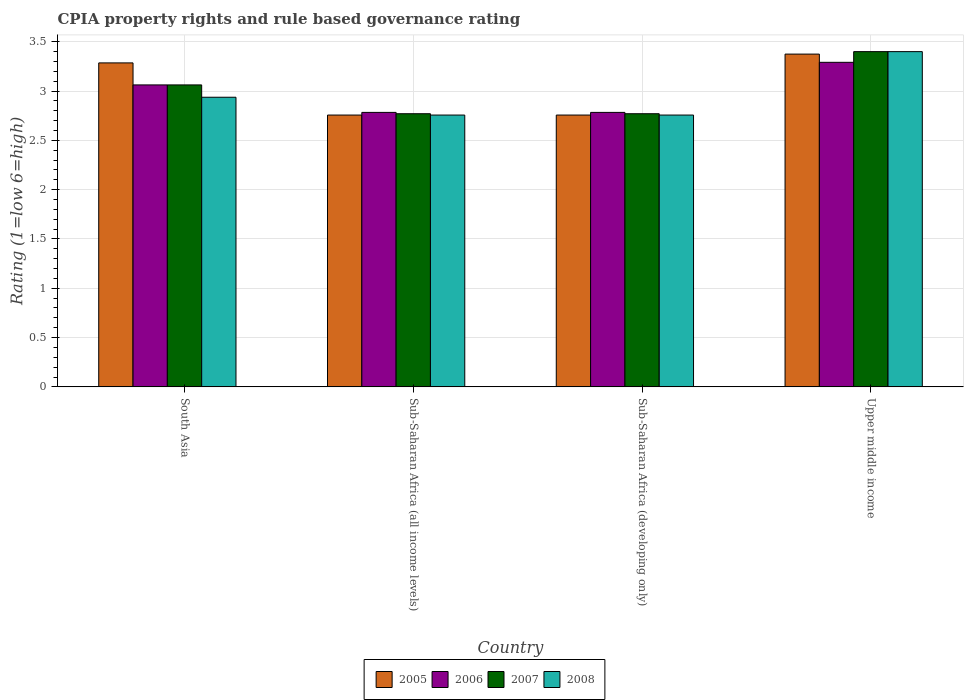How many different coloured bars are there?
Give a very brief answer. 4. Are the number of bars on each tick of the X-axis equal?
Give a very brief answer. Yes. What is the label of the 1st group of bars from the left?
Your answer should be compact. South Asia. In how many cases, is the number of bars for a given country not equal to the number of legend labels?
Provide a short and direct response. 0. What is the CPIA rating in 2008 in Sub-Saharan Africa (developing only)?
Your answer should be very brief. 2.76. Across all countries, what is the maximum CPIA rating in 2005?
Ensure brevity in your answer.  3.38. Across all countries, what is the minimum CPIA rating in 2007?
Provide a short and direct response. 2.77. In which country was the CPIA rating in 2007 maximum?
Ensure brevity in your answer.  Upper middle income. In which country was the CPIA rating in 2007 minimum?
Make the answer very short. Sub-Saharan Africa (all income levels). What is the total CPIA rating in 2006 in the graph?
Make the answer very short. 11.92. What is the difference between the CPIA rating in 2008 in South Asia and that in Sub-Saharan Africa (all income levels)?
Offer a very short reply. 0.18. What is the difference between the CPIA rating in 2008 in South Asia and the CPIA rating in 2007 in Upper middle income?
Offer a terse response. -0.46. What is the average CPIA rating in 2008 per country?
Offer a very short reply. 2.96. In how many countries, is the CPIA rating in 2006 greater than 1?
Offer a terse response. 4. What is the ratio of the CPIA rating in 2006 in South Asia to that in Sub-Saharan Africa (developing only)?
Offer a very short reply. 1.1. Is the difference between the CPIA rating in 2005 in Sub-Saharan Africa (developing only) and Upper middle income greater than the difference between the CPIA rating in 2008 in Sub-Saharan Africa (developing only) and Upper middle income?
Offer a terse response. Yes. What is the difference between the highest and the second highest CPIA rating in 2008?
Offer a terse response. -0.46. What is the difference between the highest and the lowest CPIA rating in 2005?
Make the answer very short. 0.62. What does the 3rd bar from the left in Sub-Saharan Africa (all income levels) represents?
Keep it short and to the point. 2007. How many countries are there in the graph?
Offer a very short reply. 4. What is the difference between two consecutive major ticks on the Y-axis?
Make the answer very short. 0.5. Does the graph contain any zero values?
Offer a terse response. No. Does the graph contain grids?
Give a very brief answer. Yes. How are the legend labels stacked?
Your response must be concise. Horizontal. What is the title of the graph?
Make the answer very short. CPIA property rights and rule based governance rating. Does "2008" appear as one of the legend labels in the graph?
Keep it short and to the point. Yes. What is the Rating (1=low 6=high) in 2005 in South Asia?
Provide a short and direct response. 3.29. What is the Rating (1=low 6=high) of 2006 in South Asia?
Give a very brief answer. 3.06. What is the Rating (1=low 6=high) of 2007 in South Asia?
Offer a very short reply. 3.06. What is the Rating (1=low 6=high) of 2008 in South Asia?
Your answer should be very brief. 2.94. What is the Rating (1=low 6=high) in 2005 in Sub-Saharan Africa (all income levels)?
Make the answer very short. 2.76. What is the Rating (1=low 6=high) of 2006 in Sub-Saharan Africa (all income levels)?
Make the answer very short. 2.78. What is the Rating (1=low 6=high) in 2007 in Sub-Saharan Africa (all income levels)?
Give a very brief answer. 2.77. What is the Rating (1=low 6=high) of 2008 in Sub-Saharan Africa (all income levels)?
Offer a terse response. 2.76. What is the Rating (1=low 6=high) of 2005 in Sub-Saharan Africa (developing only)?
Make the answer very short. 2.76. What is the Rating (1=low 6=high) in 2006 in Sub-Saharan Africa (developing only)?
Make the answer very short. 2.78. What is the Rating (1=low 6=high) of 2007 in Sub-Saharan Africa (developing only)?
Provide a succinct answer. 2.77. What is the Rating (1=low 6=high) of 2008 in Sub-Saharan Africa (developing only)?
Your answer should be compact. 2.76. What is the Rating (1=low 6=high) of 2005 in Upper middle income?
Your response must be concise. 3.38. What is the Rating (1=low 6=high) of 2006 in Upper middle income?
Provide a short and direct response. 3.29. What is the Rating (1=low 6=high) of 2007 in Upper middle income?
Offer a terse response. 3.4. Across all countries, what is the maximum Rating (1=low 6=high) in 2005?
Your response must be concise. 3.38. Across all countries, what is the maximum Rating (1=low 6=high) in 2006?
Provide a succinct answer. 3.29. Across all countries, what is the minimum Rating (1=low 6=high) of 2005?
Provide a succinct answer. 2.76. Across all countries, what is the minimum Rating (1=low 6=high) in 2006?
Your answer should be very brief. 2.78. Across all countries, what is the minimum Rating (1=low 6=high) in 2007?
Make the answer very short. 2.77. Across all countries, what is the minimum Rating (1=low 6=high) in 2008?
Your response must be concise. 2.76. What is the total Rating (1=low 6=high) in 2005 in the graph?
Make the answer very short. 12.17. What is the total Rating (1=low 6=high) of 2006 in the graph?
Provide a succinct answer. 11.92. What is the total Rating (1=low 6=high) of 2007 in the graph?
Make the answer very short. 12. What is the total Rating (1=low 6=high) in 2008 in the graph?
Offer a very short reply. 11.85. What is the difference between the Rating (1=low 6=high) in 2005 in South Asia and that in Sub-Saharan Africa (all income levels)?
Give a very brief answer. 0.53. What is the difference between the Rating (1=low 6=high) of 2006 in South Asia and that in Sub-Saharan Africa (all income levels)?
Give a very brief answer. 0.28. What is the difference between the Rating (1=low 6=high) in 2007 in South Asia and that in Sub-Saharan Africa (all income levels)?
Your response must be concise. 0.29. What is the difference between the Rating (1=low 6=high) in 2008 in South Asia and that in Sub-Saharan Africa (all income levels)?
Your answer should be very brief. 0.18. What is the difference between the Rating (1=low 6=high) of 2005 in South Asia and that in Sub-Saharan Africa (developing only)?
Your answer should be very brief. 0.53. What is the difference between the Rating (1=low 6=high) in 2006 in South Asia and that in Sub-Saharan Africa (developing only)?
Your response must be concise. 0.28. What is the difference between the Rating (1=low 6=high) in 2007 in South Asia and that in Sub-Saharan Africa (developing only)?
Your answer should be very brief. 0.29. What is the difference between the Rating (1=low 6=high) in 2008 in South Asia and that in Sub-Saharan Africa (developing only)?
Ensure brevity in your answer.  0.18. What is the difference between the Rating (1=low 6=high) of 2005 in South Asia and that in Upper middle income?
Give a very brief answer. -0.09. What is the difference between the Rating (1=low 6=high) in 2006 in South Asia and that in Upper middle income?
Keep it short and to the point. -0.23. What is the difference between the Rating (1=low 6=high) of 2007 in South Asia and that in Upper middle income?
Your response must be concise. -0.34. What is the difference between the Rating (1=low 6=high) in 2008 in South Asia and that in Upper middle income?
Ensure brevity in your answer.  -0.46. What is the difference between the Rating (1=low 6=high) of 2008 in Sub-Saharan Africa (all income levels) and that in Sub-Saharan Africa (developing only)?
Your answer should be very brief. 0. What is the difference between the Rating (1=low 6=high) in 2005 in Sub-Saharan Africa (all income levels) and that in Upper middle income?
Your answer should be very brief. -0.62. What is the difference between the Rating (1=low 6=high) in 2006 in Sub-Saharan Africa (all income levels) and that in Upper middle income?
Make the answer very short. -0.51. What is the difference between the Rating (1=low 6=high) in 2007 in Sub-Saharan Africa (all income levels) and that in Upper middle income?
Offer a very short reply. -0.63. What is the difference between the Rating (1=low 6=high) in 2008 in Sub-Saharan Africa (all income levels) and that in Upper middle income?
Your answer should be compact. -0.64. What is the difference between the Rating (1=low 6=high) in 2005 in Sub-Saharan Africa (developing only) and that in Upper middle income?
Your answer should be compact. -0.62. What is the difference between the Rating (1=low 6=high) of 2006 in Sub-Saharan Africa (developing only) and that in Upper middle income?
Offer a very short reply. -0.51. What is the difference between the Rating (1=low 6=high) in 2007 in Sub-Saharan Africa (developing only) and that in Upper middle income?
Provide a short and direct response. -0.63. What is the difference between the Rating (1=low 6=high) of 2008 in Sub-Saharan Africa (developing only) and that in Upper middle income?
Give a very brief answer. -0.64. What is the difference between the Rating (1=low 6=high) in 2005 in South Asia and the Rating (1=low 6=high) in 2006 in Sub-Saharan Africa (all income levels)?
Provide a succinct answer. 0.5. What is the difference between the Rating (1=low 6=high) in 2005 in South Asia and the Rating (1=low 6=high) in 2007 in Sub-Saharan Africa (all income levels)?
Make the answer very short. 0.52. What is the difference between the Rating (1=low 6=high) of 2005 in South Asia and the Rating (1=low 6=high) of 2008 in Sub-Saharan Africa (all income levels)?
Keep it short and to the point. 0.53. What is the difference between the Rating (1=low 6=high) in 2006 in South Asia and the Rating (1=low 6=high) in 2007 in Sub-Saharan Africa (all income levels)?
Keep it short and to the point. 0.29. What is the difference between the Rating (1=low 6=high) in 2006 in South Asia and the Rating (1=low 6=high) in 2008 in Sub-Saharan Africa (all income levels)?
Keep it short and to the point. 0.31. What is the difference between the Rating (1=low 6=high) in 2007 in South Asia and the Rating (1=low 6=high) in 2008 in Sub-Saharan Africa (all income levels)?
Give a very brief answer. 0.31. What is the difference between the Rating (1=low 6=high) of 2005 in South Asia and the Rating (1=low 6=high) of 2006 in Sub-Saharan Africa (developing only)?
Keep it short and to the point. 0.5. What is the difference between the Rating (1=low 6=high) of 2005 in South Asia and the Rating (1=low 6=high) of 2007 in Sub-Saharan Africa (developing only)?
Your answer should be compact. 0.52. What is the difference between the Rating (1=low 6=high) in 2005 in South Asia and the Rating (1=low 6=high) in 2008 in Sub-Saharan Africa (developing only)?
Make the answer very short. 0.53. What is the difference between the Rating (1=low 6=high) in 2006 in South Asia and the Rating (1=low 6=high) in 2007 in Sub-Saharan Africa (developing only)?
Give a very brief answer. 0.29. What is the difference between the Rating (1=low 6=high) of 2006 in South Asia and the Rating (1=low 6=high) of 2008 in Sub-Saharan Africa (developing only)?
Give a very brief answer. 0.31. What is the difference between the Rating (1=low 6=high) of 2007 in South Asia and the Rating (1=low 6=high) of 2008 in Sub-Saharan Africa (developing only)?
Offer a very short reply. 0.31. What is the difference between the Rating (1=low 6=high) of 2005 in South Asia and the Rating (1=low 6=high) of 2006 in Upper middle income?
Your answer should be compact. -0.01. What is the difference between the Rating (1=low 6=high) of 2005 in South Asia and the Rating (1=low 6=high) of 2007 in Upper middle income?
Your answer should be very brief. -0.11. What is the difference between the Rating (1=low 6=high) of 2005 in South Asia and the Rating (1=low 6=high) of 2008 in Upper middle income?
Offer a terse response. -0.11. What is the difference between the Rating (1=low 6=high) in 2006 in South Asia and the Rating (1=low 6=high) in 2007 in Upper middle income?
Make the answer very short. -0.34. What is the difference between the Rating (1=low 6=high) in 2006 in South Asia and the Rating (1=low 6=high) in 2008 in Upper middle income?
Offer a terse response. -0.34. What is the difference between the Rating (1=low 6=high) in 2007 in South Asia and the Rating (1=low 6=high) in 2008 in Upper middle income?
Provide a succinct answer. -0.34. What is the difference between the Rating (1=low 6=high) in 2005 in Sub-Saharan Africa (all income levels) and the Rating (1=low 6=high) in 2006 in Sub-Saharan Africa (developing only)?
Give a very brief answer. -0.03. What is the difference between the Rating (1=low 6=high) of 2005 in Sub-Saharan Africa (all income levels) and the Rating (1=low 6=high) of 2007 in Sub-Saharan Africa (developing only)?
Give a very brief answer. -0.01. What is the difference between the Rating (1=low 6=high) in 2006 in Sub-Saharan Africa (all income levels) and the Rating (1=low 6=high) in 2007 in Sub-Saharan Africa (developing only)?
Your response must be concise. 0.01. What is the difference between the Rating (1=low 6=high) of 2006 in Sub-Saharan Africa (all income levels) and the Rating (1=low 6=high) of 2008 in Sub-Saharan Africa (developing only)?
Provide a short and direct response. 0.03. What is the difference between the Rating (1=low 6=high) of 2007 in Sub-Saharan Africa (all income levels) and the Rating (1=low 6=high) of 2008 in Sub-Saharan Africa (developing only)?
Make the answer very short. 0.01. What is the difference between the Rating (1=low 6=high) of 2005 in Sub-Saharan Africa (all income levels) and the Rating (1=low 6=high) of 2006 in Upper middle income?
Make the answer very short. -0.53. What is the difference between the Rating (1=low 6=high) in 2005 in Sub-Saharan Africa (all income levels) and the Rating (1=low 6=high) in 2007 in Upper middle income?
Your answer should be compact. -0.64. What is the difference between the Rating (1=low 6=high) of 2005 in Sub-Saharan Africa (all income levels) and the Rating (1=low 6=high) of 2008 in Upper middle income?
Keep it short and to the point. -0.64. What is the difference between the Rating (1=low 6=high) of 2006 in Sub-Saharan Africa (all income levels) and the Rating (1=low 6=high) of 2007 in Upper middle income?
Your response must be concise. -0.62. What is the difference between the Rating (1=low 6=high) of 2006 in Sub-Saharan Africa (all income levels) and the Rating (1=low 6=high) of 2008 in Upper middle income?
Provide a succinct answer. -0.62. What is the difference between the Rating (1=low 6=high) in 2007 in Sub-Saharan Africa (all income levels) and the Rating (1=low 6=high) in 2008 in Upper middle income?
Offer a very short reply. -0.63. What is the difference between the Rating (1=low 6=high) of 2005 in Sub-Saharan Africa (developing only) and the Rating (1=low 6=high) of 2006 in Upper middle income?
Keep it short and to the point. -0.53. What is the difference between the Rating (1=low 6=high) of 2005 in Sub-Saharan Africa (developing only) and the Rating (1=low 6=high) of 2007 in Upper middle income?
Your response must be concise. -0.64. What is the difference between the Rating (1=low 6=high) of 2005 in Sub-Saharan Africa (developing only) and the Rating (1=low 6=high) of 2008 in Upper middle income?
Offer a terse response. -0.64. What is the difference between the Rating (1=low 6=high) of 2006 in Sub-Saharan Africa (developing only) and the Rating (1=low 6=high) of 2007 in Upper middle income?
Provide a short and direct response. -0.62. What is the difference between the Rating (1=low 6=high) of 2006 in Sub-Saharan Africa (developing only) and the Rating (1=low 6=high) of 2008 in Upper middle income?
Your answer should be very brief. -0.62. What is the difference between the Rating (1=low 6=high) in 2007 in Sub-Saharan Africa (developing only) and the Rating (1=low 6=high) in 2008 in Upper middle income?
Provide a short and direct response. -0.63. What is the average Rating (1=low 6=high) of 2005 per country?
Keep it short and to the point. 3.04. What is the average Rating (1=low 6=high) in 2006 per country?
Ensure brevity in your answer.  2.98. What is the average Rating (1=low 6=high) in 2007 per country?
Provide a short and direct response. 3. What is the average Rating (1=low 6=high) in 2008 per country?
Your response must be concise. 2.96. What is the difference between the Rating (1=low 6=high) of 2005 and Rating (1=low 6=high) of 2006 in South Asia?
Ensure brevity in your answer.  0.22. What is the difference between the Rating (1=low 6=high) of 2005 and Rating (1=low 6=high) of 2007 in South Asia?
Your response must be concise. 0.22. What is the difference between the Rating (1=low 6=high) of 2005 and Rating (1=low 6=high) of 2008 in South Asia?
Ensure brevity in your answer.  0.35. What is the difference between the Rating (1=low 6=high) of 2006 and Rating (1=low 6=high) of 2008 in South Asia?
Provide a succinct answer. 0.12. What is the difference between the Rating (1=low 6=high) of 2005 and Rating (1=low 6=high) of 2006 in Sub-Saharan Africa (all income levels)?
Your answer should be compact. -0.03. What is the difference between the Rating (1=low 6=high) of 2005 and Rating (1=low 6=high) of 2007 in Sub-Saharan Africa (all income levels)?
Offer a terse response. -0.01. What is the difference between the Rating (1=low 6=high) in 2005 and Rating (1=low 6=high) in 2008 in Sub-Saharan Africa (all income levels)?
Your answer should be very brief. 0. What is the difference between the Rating (1=low 6=high) of 2006 and Rating (1=low 6=high) of 2007 in Sub-Saharan Africa (all income levels)?
Provide a succinct answer. 0.01. What is the difference between the Rating (1=low 6=high) of 2006 and Rating (1=low 6=high) of 2008 in Sub-Saharan Africa (all income levels)?
Your response must be concise. 0.03. What is the difference between the Rating (1=low 6=high) of 2007 and Rating (1=low 6=high) of 2008 in Sub-Saharan Africa (all income levels)?
Make the answer very short. 0.01. What is the difference between the Rating (1=low 6=high) in 2005 and Rating (1=low 6=high) in 2006 in Sub-Saharan Africa (developing only)?
Give a very brief answer. -0.03. What is the difference between the Rating (1=low 6=high) in 2005 and Rating (1=low 6=high) in 2007 in Sub-Saharan Africa (developing only)?
Give a very brief answer. -0.01. What is the difference between the Rating (1=low 6=high) of 2005 and Rating (1=low 6=high) of 2008 in Sub-Saharan Africa (developing only)?
Your answer should be very brief. 0. What is the difference between the Rating (1=low 6=high) of 2006 and Rating (1=low 6=high) of 2007 in Sub-Saharan Africa (developing only)?
Provide a succinct answer. 0.01. What is the difference between the Rating (1=low 6=high) in 2006 and Rating (1=low 6=high) in 2008 in Sub-Saharan Africa (developing only)?
Your response must be concise. 0.03. What is the difference between the Rating (1=low 6=high) in 2007 and Rating (1=low 6=high) in 2008 in Sub-Saharan Africa (developing only)?
Offer a terse response. 0.01. What is the difference between the Rating (1=low 6=high) of 2005 and Rating (1=low 6=high) of 2006 in Upper middle income?
Offer a very short reply. 0.08. What is the difference between the Rating (1=low 6=high) in 2005 and Rating (1=low 6=high) in 2007 in Upper middle income?
Offer a very short reply. -0.03. What is the difference between the Rating (1=low 6=high) in 2005 and Rating (1=low 6=high) in 2008 in Upper middle income?
Your answer should be very brief. -0.03. What is the difference between the Rating (1=low 6=high) of 2006 and Rating (1=low 6=high) of 2007 in Upper middle income?
Give a very brief answer. -0.11. What is the difference between the Rating (1=low 6=high) in 2006 and Rating (1=low 6=high) in 2008 in Upper middle income?
Give a very brief answer. -0.11. What is the ratio of the Rating (1=low 6=high) of 2005 in South Asia to that in Sub-Saharan Africa (all income levels)?
Your answer should be very brief. 1.19. What is the ratio of the Rating (1=low 6=high) of 2006 in South Asia to that in Sub-Saharan Africa (all income levels)?
Give a very brief answer. 1.1. What is the ratio of the Rating (1=low 6=high) in 2007 in South Asia to that in Sub-Saharan Africa (all income levels)?
Offer a very short reply. 1.11. What is the ratio of the Rating (1=low 6=high) of 2008 in South Asia to that in Sub-Saharan Africa (all income levels)?
Ensure brevity in your answer.  1.07. What is the ratio of the Rating (1=low 6=high) in 2005 in South Asia to that in Sub-Saharan Africa (developing only)?
Make the answer very short. 1.19. What is the ratio of the Rating (1=low 6=high) of 2006 in South Asia to that in Sub-Saharan Africa (developing only)?
Offer a terse response. 1.1. What is the ratio of the Rating (1=low 6=high) in 2007 in South Asia to that in Sub-Saharan Africa (developing only)?
Your answer should be very brief. 1.11. What is the ratio of the Rating (1=low 6=high) in 2008 in South Asia to that in Sub-Saharan Africa (developing only)?
Give a very brief answer. 1.07. What is the ratio of the Rating (1=low 6=high) in 2005 in South Asia to that in Upper middle income?
Offer a terse response. 0.97. What is the ratio of the Rating (1=low 6=high) in 2006 in South Asia to that in Upper middle income?
Keep it short and to the point. 0.93. What is the ratio of the Rating (1=low 6=high) of 2007 in South Asia to that in Upper middle income?
Provide a succinct answer. 0.9. What is the ratio of the Rating (1=low 6=high) of 2008 in South Asia to that in Upper middle income?
Your answer should be compact. 0.86. What is the ratio of the Rating (1=low 6=high) in 2008 in Sub-Saharan Africa (all income levels) to that in Sub-Saharan Africa (developing only)?
Your answer should be compact. 1. What is the ratio of the Rating (1=low 6=high) in 2005 in Sub-Saharan Africa (all income levels) to that in Upper middle income?
Provide a short and direct response. 0.82. What is the ratio of the Rating (1=low 6=high) of 2006 in Sub-Saharan Africa (all income levels) to that in Upper middle income?
Your answer should be compact. 0.85. What is the ratio of the Rating (1=low 6=high) in 2007 in Sub-Saharan Africa (all income levels) to that in Upper middle income?
Your answer should be compact. 0.81. What is the ratio of the Rating (1=low 6=high) of 2008 in Sub-Saharan Africa (all income levels) to that in Upper middle income?
Your response must be concise. 0.81. What is the ratio of the Rating (1=low 6=high) of 2005 in Sub-Saharan Africa (developing only) to that in Upper middle income?
Your answer should be compact. 0.82. What is the ratio of the Rating (1=low 6=high) in 2006 in Sub-Saharan Africa (developing only) to that in Upper middle income?
Your answer should be compact. 0.85. What is the ratio of the Rating (1=low 6=high) of 2007 in Sub-Saharan Africa (developing only) to that in Upper middle income?
Provide a succinct answer. 0.81. What is the ratio of the Rating (1=low 6=high) of 2008 in Sub-Saharan Africa (developing only) to that in Upper middle income?
Provide a succinct answer. 0.81. What is the difference between the highest and the second highest Rating (1=low 6=high) of 2005?
Ensure brevity in your answer.  0.09. What is the difference between the highest and the second highest Rating (1=low 6=high) in 2006?
Your answer should be very brief. 0.23. What is the difference between the highest and the second highest Rating (1=low 6=high) in 2007?
Give a very brief answer. 0.34. What is the difference between the highest and the second highest Rating (1=low 6=high) of 2008?
Your answer should be compact. 0.46. What is the difference between the highest and the lowest Rating (1=low 6=high) of 2005?
Provide a short and direct response. 0.62. What is the difference between the highest and the lowest Rating (1=low 6=high) in 2006?
Your answer should be compact. 0.51. What is the difference between the highest and the lowest Rating (1=low 6=high) of 2007?
Your answer should be compact. 0.63. What is the difference between the highest and the lowest Rating (1=low 6=high) in 2008?
Offer a terse response. 0.64. 